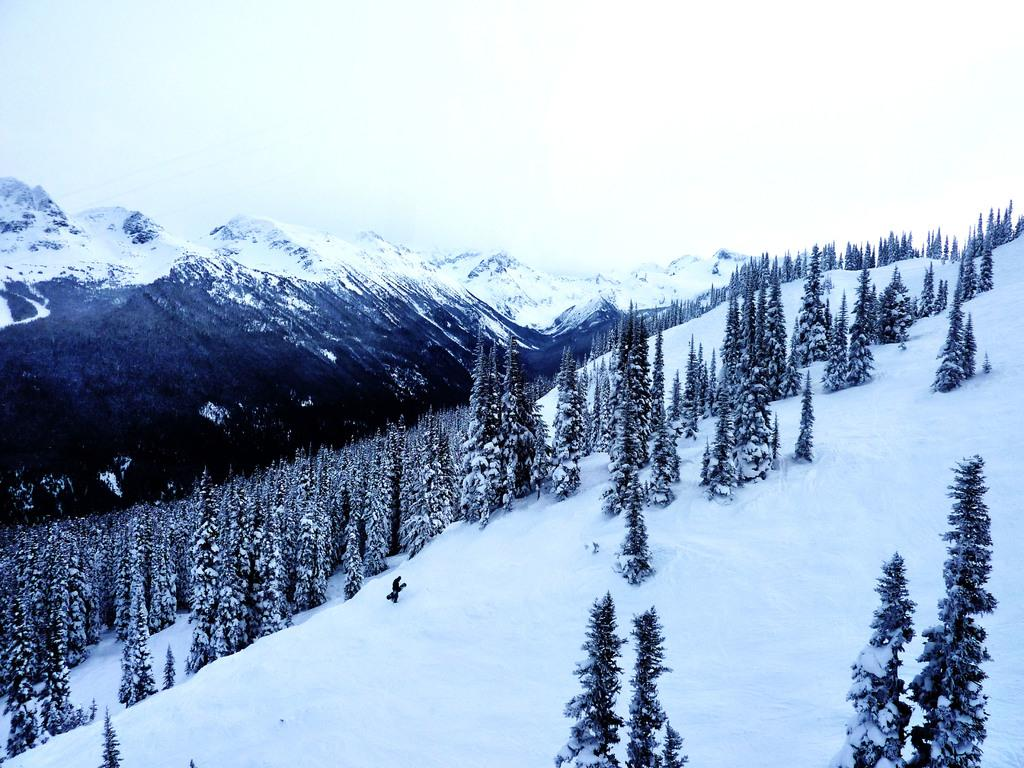What is the condition of the ground in the image? The ground is covered in snow. What can be seen on the snow-covered ground? There are trees on the snow-covered ground. What is visible in the background of the image? There are mountains visible in the background of the image. What type of feast is being prepared in the image? There is no indication of a feast or any food preparation in the image. 